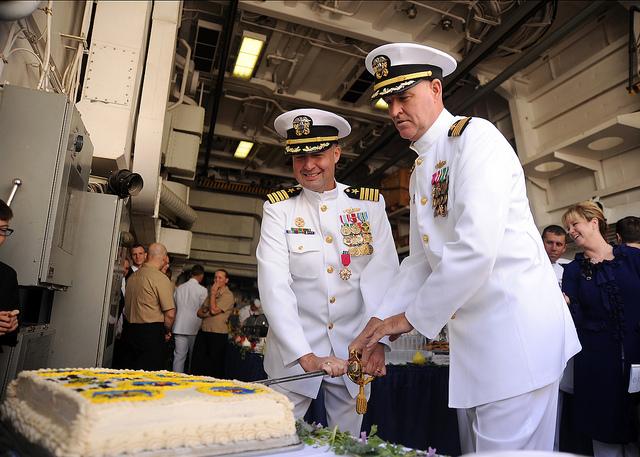What is the men wearing on their head?
Short answer required. Hats. Where is this occurring?
Short answer required. Boat. Do the men have a mask in their mouth?
Concise answer only. No. What branch of service do these men represent?
Answer briefly. Navy. Are the men's hats all alike?
Write a very short answer. Yes. Why are these two people wearing hats?
Write a very short answer. Military. What color are the men's suits?
Give a very brief answer. White. What is on top of the man's head?
Be succinct. Hat. Is this a wine tasting function?
Concise answer only. No. In what service industry might these two be employed?
Short answer required. Navy. How many sailors are in this image?
Be succinct. 2. What are they wearing on their heads?
Concise answer only. Hats. Are these men elderly?
Quick response, please. No. What is on their heads?
Concise answer only. Hats. Is this a retirement or going away party?
Write a very short answer. Retirement. Why do the men cover their heads?
Give a very brief answer. Respect. What team is on the man's hat?
Give a very brief answer. Navy. Does it really require two people to cut the item shown?
Quick response, please. No. What color is the man's hat?
Be succinct. White. What branch of the military does the man belong to?
Answer briefly. Navy. What are the men cutting?
Keep it brief. Cake. Does the cake have red stripes on it?
Concise answer only. No. What profession do these people have?
Answer briefly. Military. Why is the man wearing a head covering?
Answer briefly. Navy. What is depicted on the cake?
Answer briefly. Frosting. Is the man traveling?
Write a very short answer. No. 